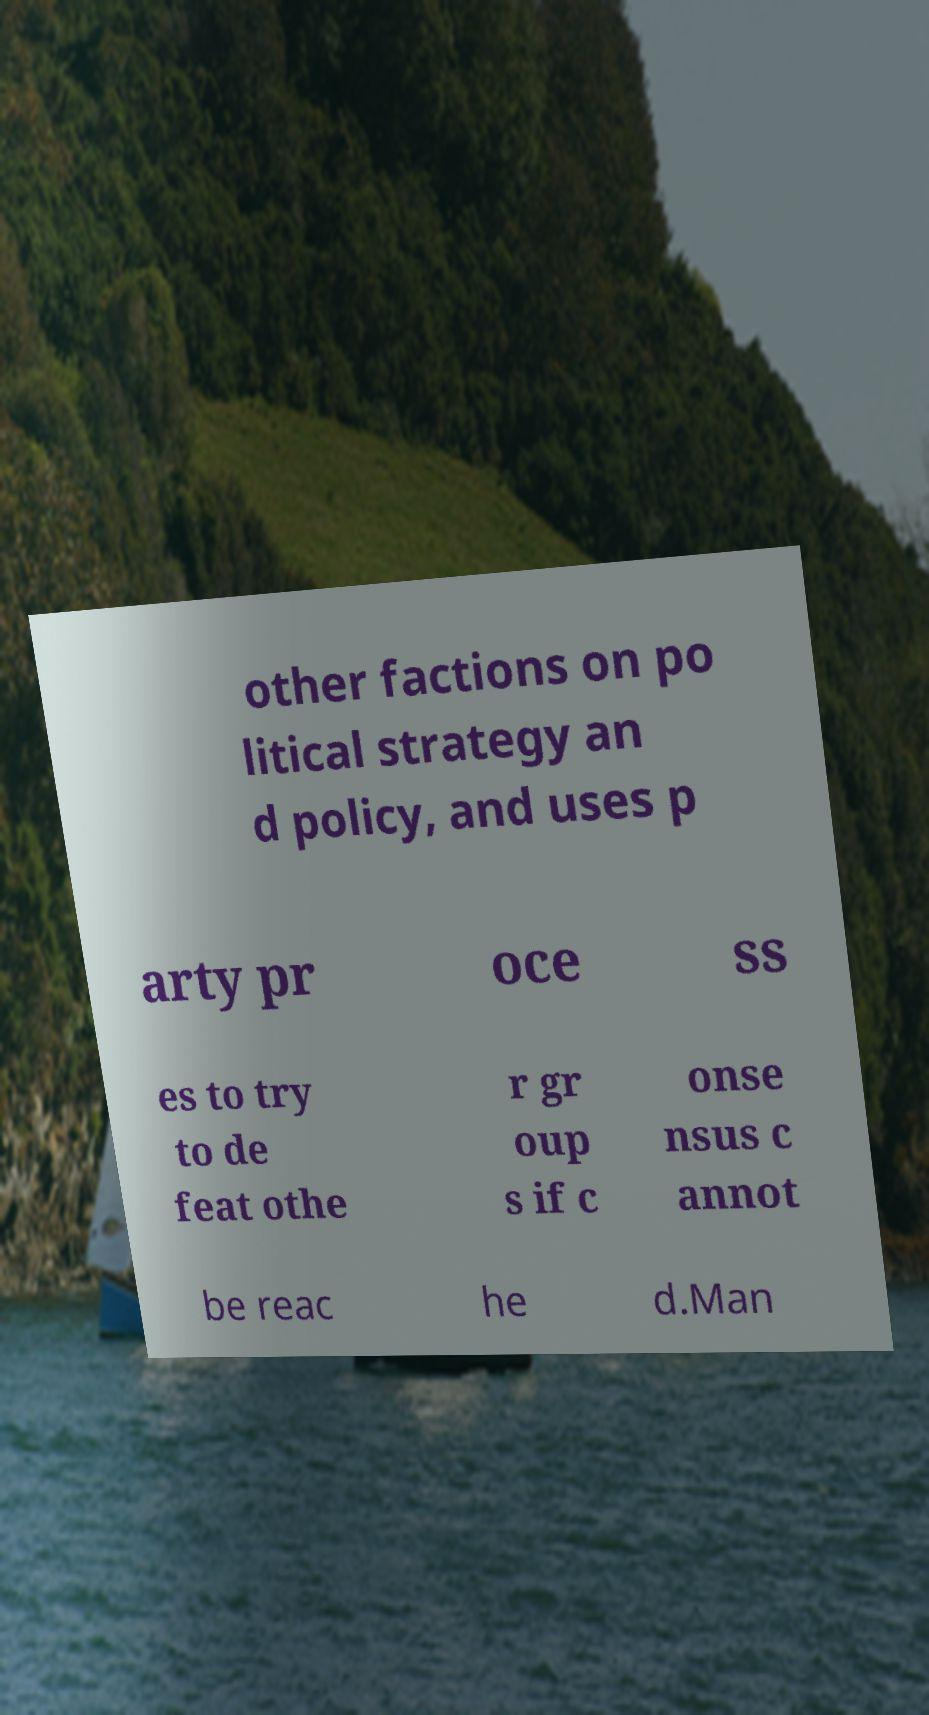Please identify and transcribe the text found in this image. other factions on po litical strategy an d policy, and uses p arty pr oce ss es to try to de feat othe r gr oup s if c onse nsus c annot be reac he d.Man 